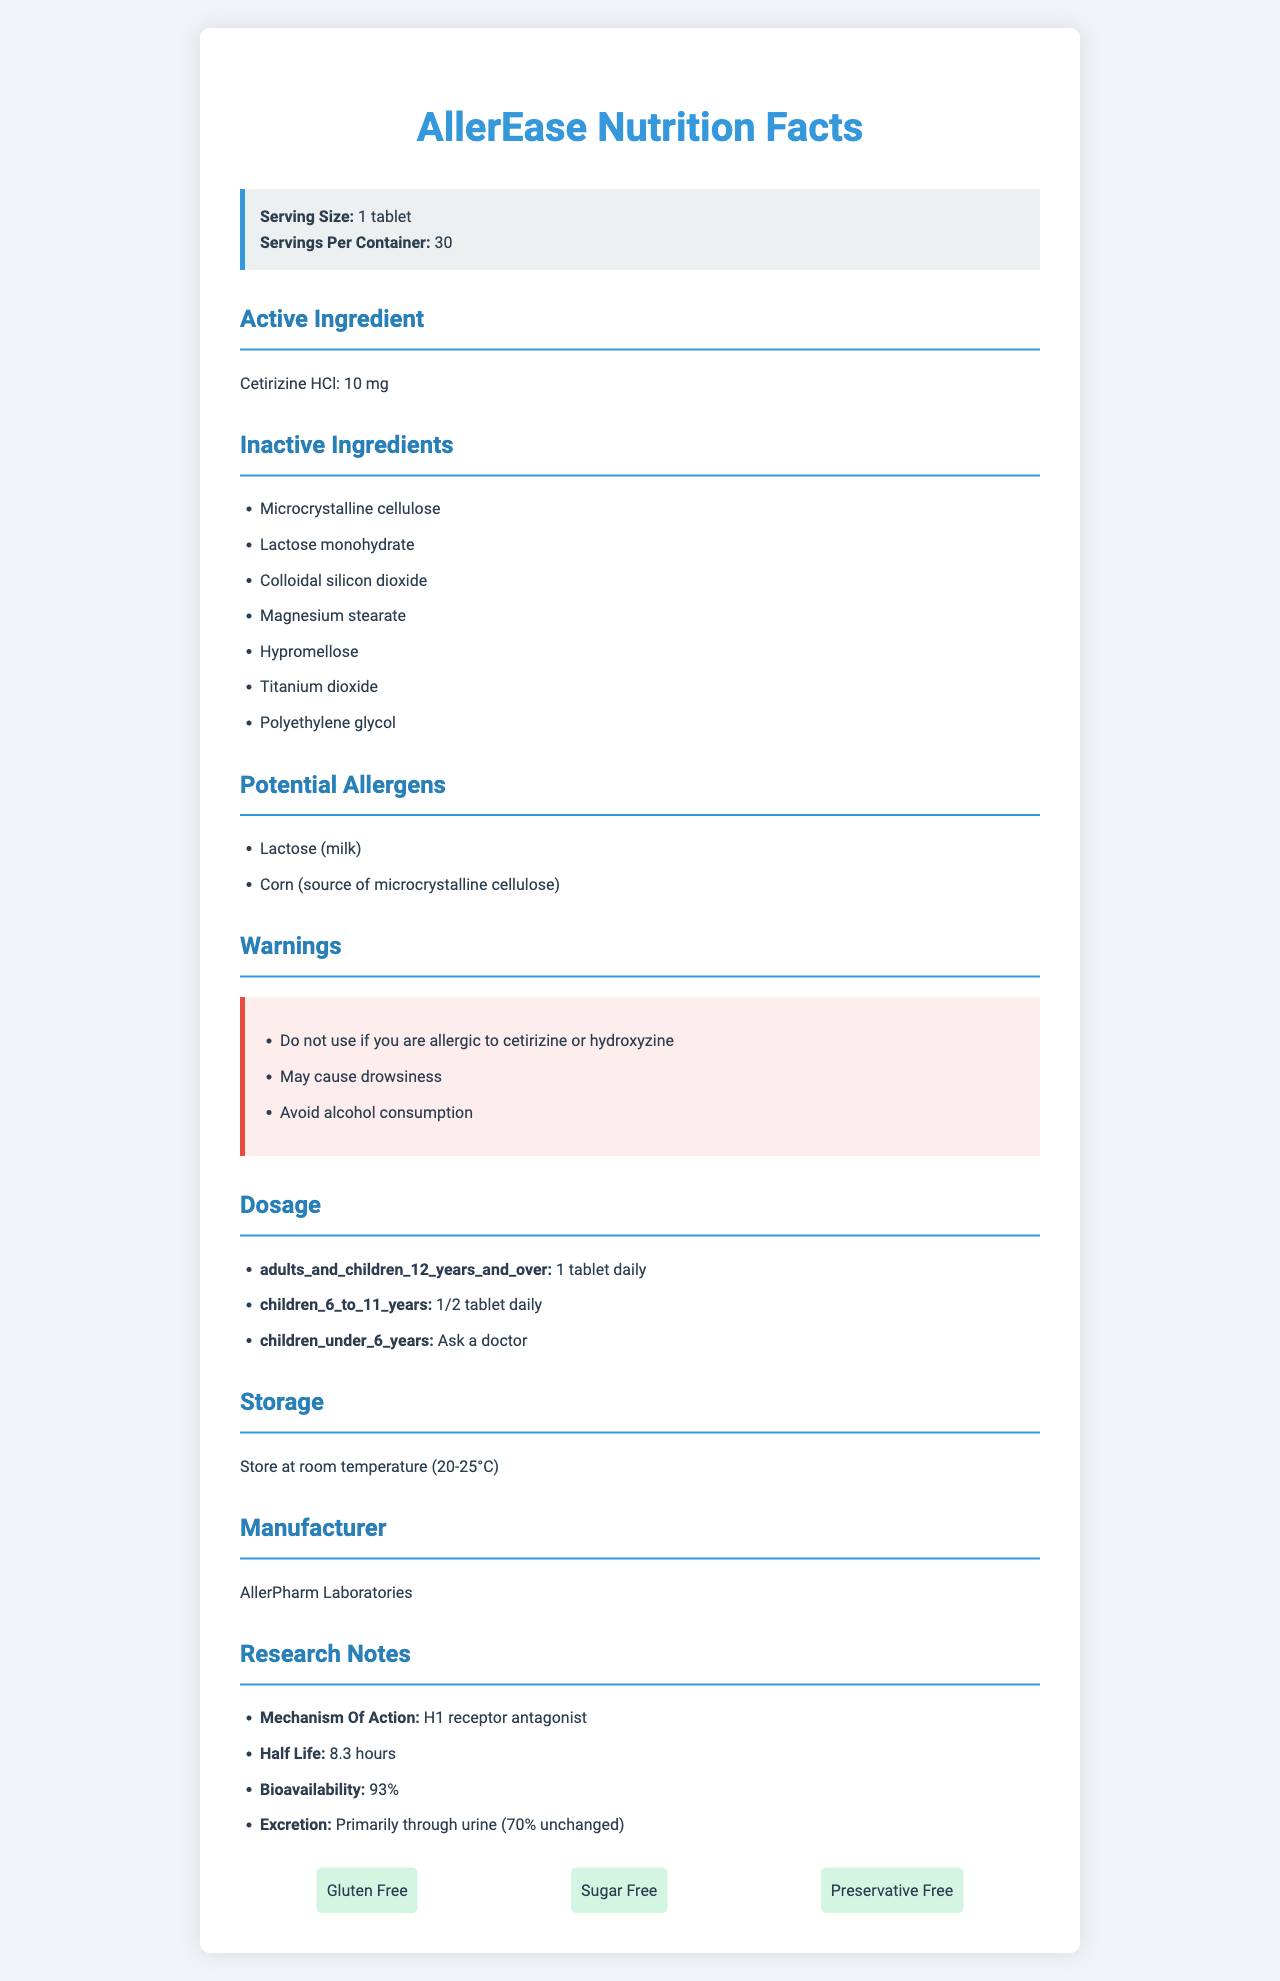what is the serving size? According to the document, the serving size is listed as 1 tablet.
Answer: 1 tablet how many tablets are there in one container? The document states there are 30 servings per container, and each serving is 1 tablet.
Answer: 30 what is the active ingredient and its amount per serving? The document specifies that the active ingredient is Cetirizine HCl, and the amount per serving is 10 mg.
Answer: Cetirizine HCl, 10 mg Name two inactive ingredients present in the medication. The document lists several inactive ingredients, including microcrystalline cellulose and lactose monohydrate.
Answer: Microcrystalline cellulose, Lactose monohydrate what is one of the warnings provided on the document? One of the warnings listed in the document states "Do not use if you are allergic to cetirizine or hydroxyzine."
Answer: Do not use if you are allergic to cetirizine or hydroxyzine which age group should ask a doctor before taking this medication? A. Adults and children 12 years and over B. Children 6 to 11 years C. Children under 6 years D. All of the above The document indicates that children under 6 years should ask a doctor before taking this medication.
Answer: C what are the potential allergens listed? A. Lactose (milk) and gluten B. Corn (source of microcrystalline cellulose) and dairy C. Lactose (milk) and corn (source of microcrystalline cellulose) D. Gluten and corn The potential allergens listed in the document are lactose (milk) and corn (source of microcrystalline cellulose).
Answer: C are the contents of this medication gluten-free? The additional information section specifies that the medication is gluten-free.
Answer: Yes summarize the document. The document offers a comprehensive view of the medication AllerEase, from its constituents and potential allergens to usage guidelines and safety warnings, along with additional scientific and supplementary information.
Answer: The AllerEase Nutrition Facts document provides an overview of the medication, listing details such as serving size, concentration of active and inactive ingredients, potential allergens, warnings, dosage instructions for different age groups, storage conditions, and manufacturer information. Additional research notes, safety features, and highlights like being gluten-free, sugar-free, and preservative-free are also included. what is the manufacturer of this medication? The manufacturer is listed as AllerPharm Laboratories in the document.
Answer: AllerPharm Laboratories what is the half-life of Cetirizine HCl according to the research notes? The research notes specify that the half-life of Cetirizine HCl is 8.3 hours.
Answer: 8.3 hours how should the medication be stored? The document advises storing the medication at room temperature (20-25°C).
Answer: Store at room temperature (20-25°C) does this medication contain sugar or preservatives? The additional information specifies that the medication is sugar-free and preservative-free.
Answer: No are there age restrictions on dosage for this medication? The dosage section in the document outlines different dosages for various age groups, indicating restrictions.
Answer: Yes how is Cetirizine HCl primarily excreted from the body? According to the research notes, Cetirizine HCl is primarily excreted through urine, with 70% unchanged.
Answer: Primarily through urine (70% unchanged) what is the mechanism of action for Cetirizine HCl? The research notes state that the mechanism of action for Cetirizine HCl is as an H1 receptor antagonist.
Answer: H1 receptor antagonist which warning directly relates to another ingredient in the medication apart from Cetirizine HCl? This warning relates to hydroxyzine, which is not the main active ingredient but is mentioned in the warning section.
Answer: Do not use if you are allergic to hydroxyzine what colorant is included in the inactive ingredients? The list of inactive ingredients includes titanium dioxide, which is a commonly used colorant.
Answer: Titanium dioxide what is the specific substance in the inactive ingredient list that could cause an allergic reaction in individuals with a milk allergy? Lactose monohydrate is derived from milk and could cause an allergic reaction in individuals with a milk allergy.
Answer: Lactose monohydrate what is the recommended dosage for children aged 6 to 11 years? According to the dosage section, the recommended dosage for children aged 6 to 11 years is 1/2 tablet daily.
Answer: 1/2 tablet daily what is the bioavailability of Cetirizine HCl according to the research notes? The bioavailability of Cetirizine HCl is listed as 93% in the research notes.
Answer: 93% are there any ingredients derived from corn in this medication? The document lists microcrystalline cellulose, which is derived from corn, as a potential allergen.
Answer: Yes what is the total number of potential allergen types listed? The document lists two potential allergens: lactose (milk) and corn (source of microcrystalline cellulose).
Answer: 2 what does the "HCl" in Cetirizine HCl stand for? The document does not provide information about what "HCl" stands for in Cetirizine HCl.
Answer: Cannot be determined 